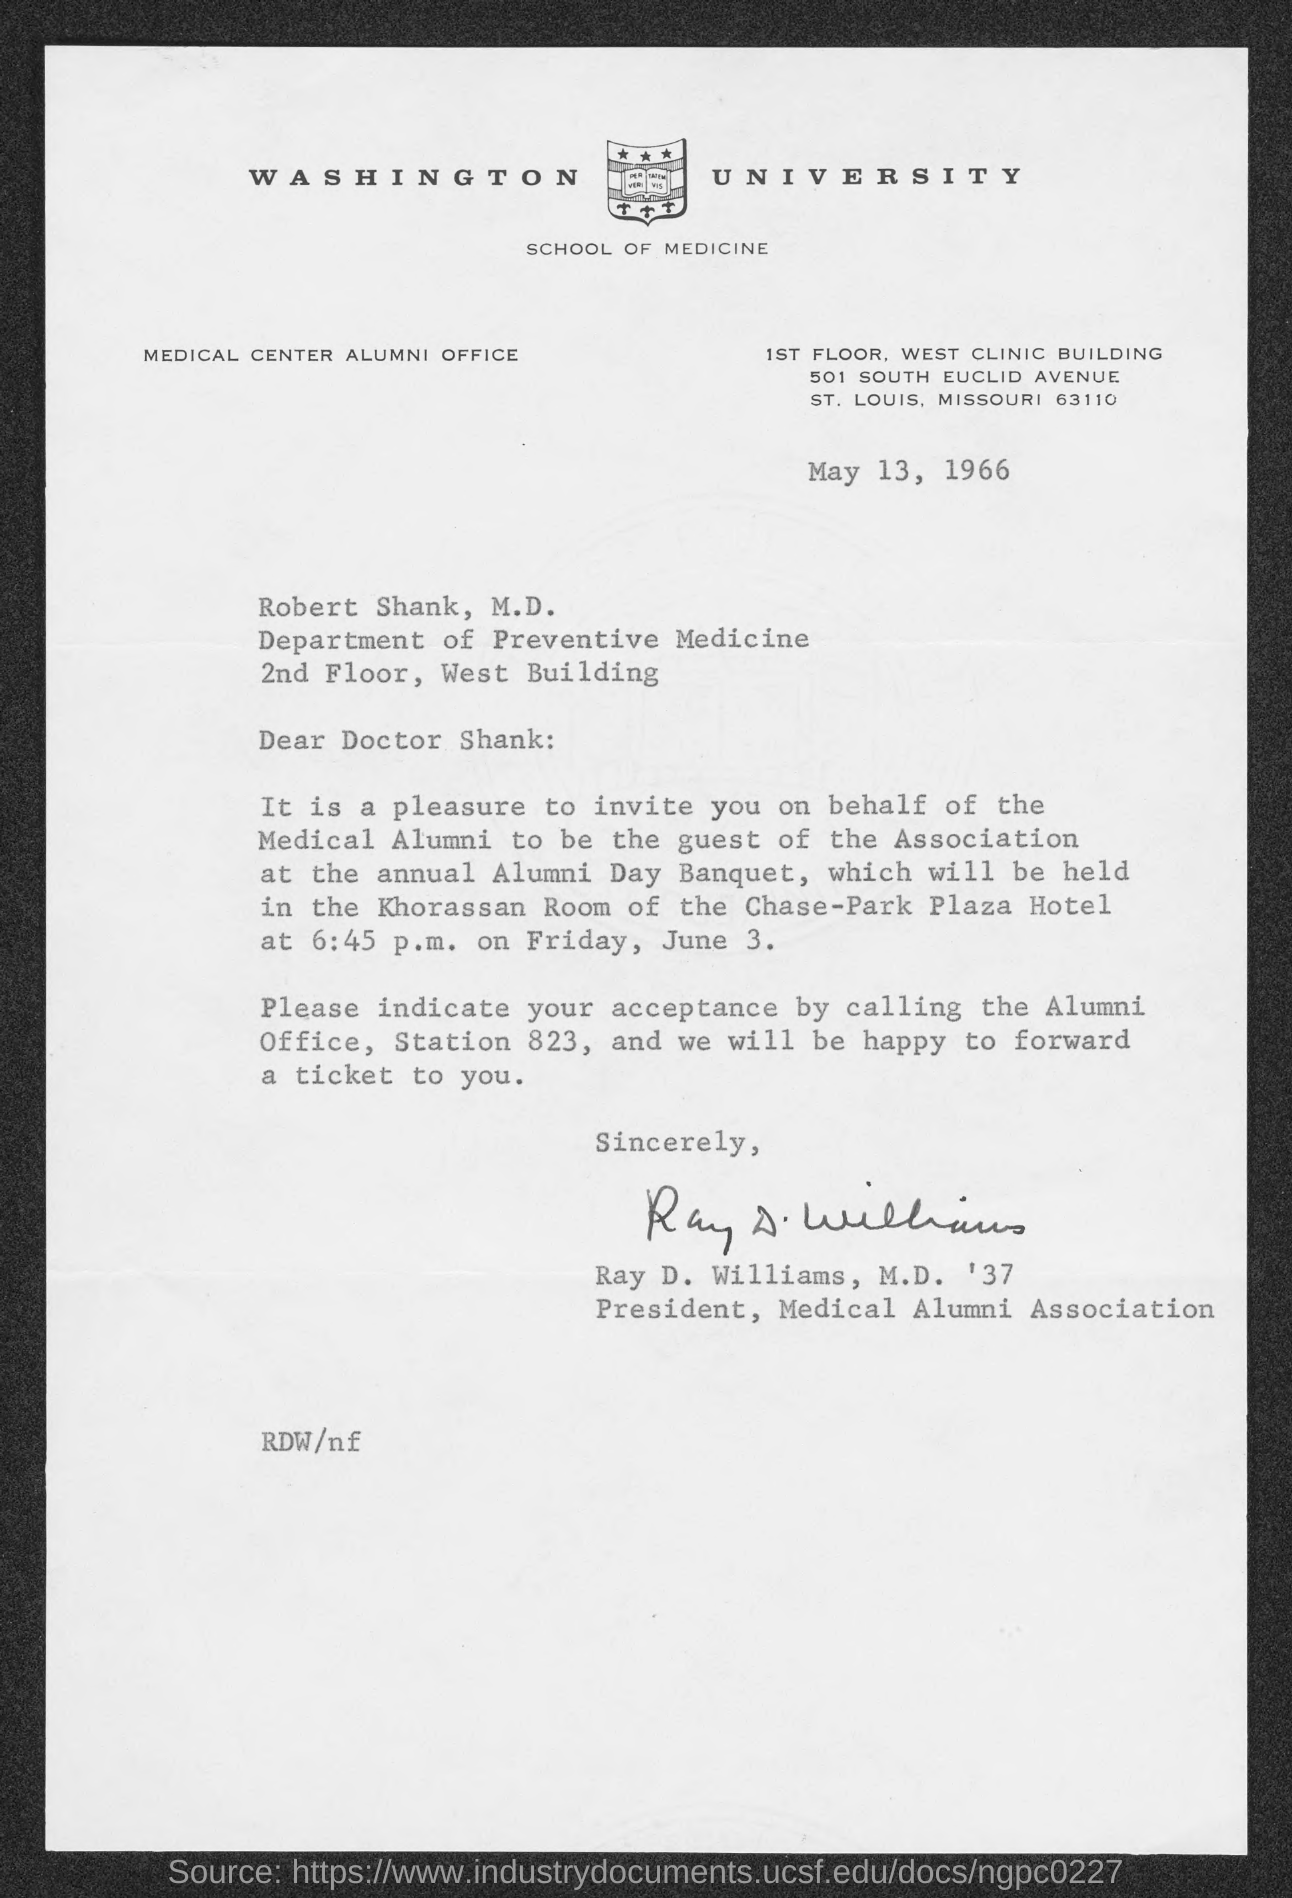Which University is mentioned in the letter head?
Offer a very short reply. Washington University. What is the issued date of this letter?
Give a very brief answer. May 13, 1966. In which department, Dr. Robert Shank M.D. works?
Offer a very short reply. Department of Preventive Medicine. What is the designation of Ray D. Williams, M.D. '37?
Ensure brevity in your answer.  President, Medical Alumni Association. Who has signed this letter?
Your response must be concise. Ray D. Williams, M.D. '37. 